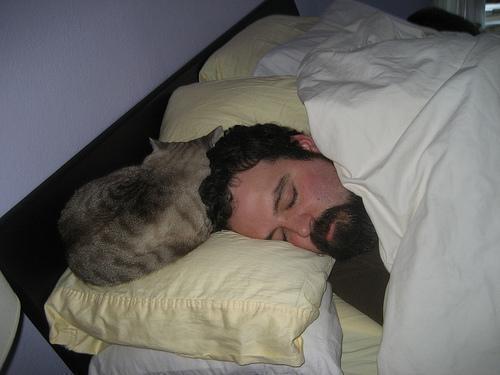How many people do you see?
Give a very brief answer. 1. 